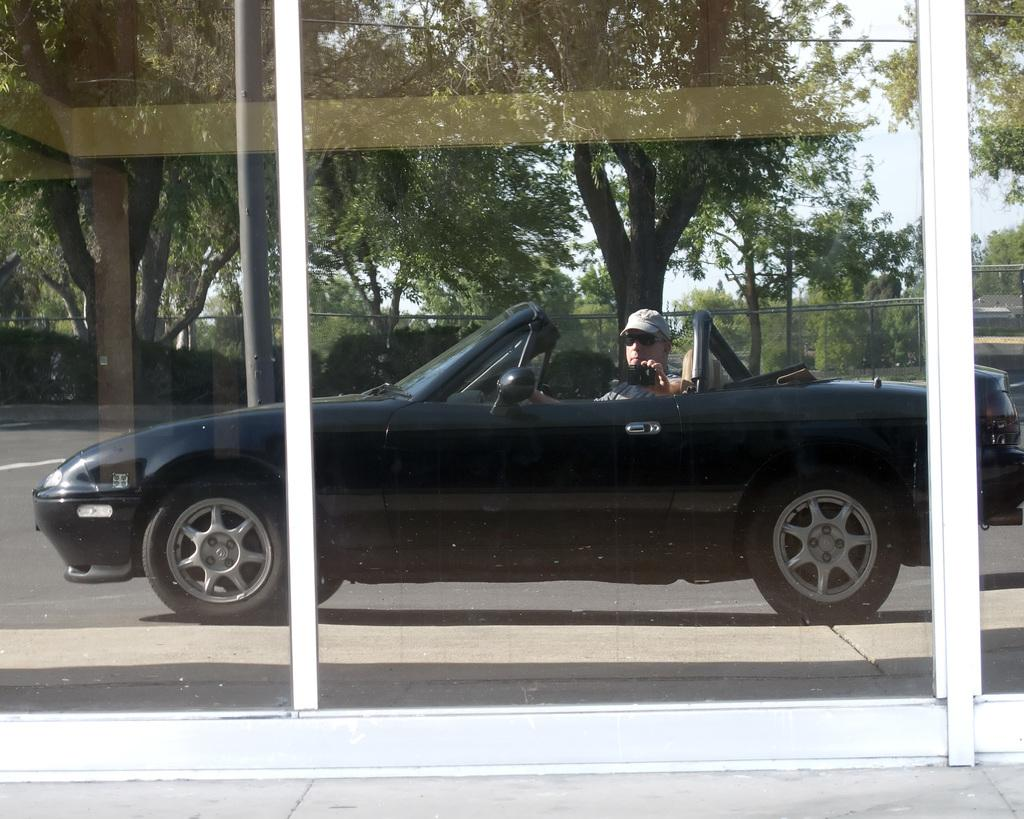What is the person in the car doing? The person is sitting in a car. What is the person holding in the image? The person is holding an object. What can be seen in the background of the image? There are trees and a fence in the background of the image. What type of pain is the person experiencing while sitting in the car? There is no indication in the image that the person is experiencing any pain, so it cannot be determined from the picture. 